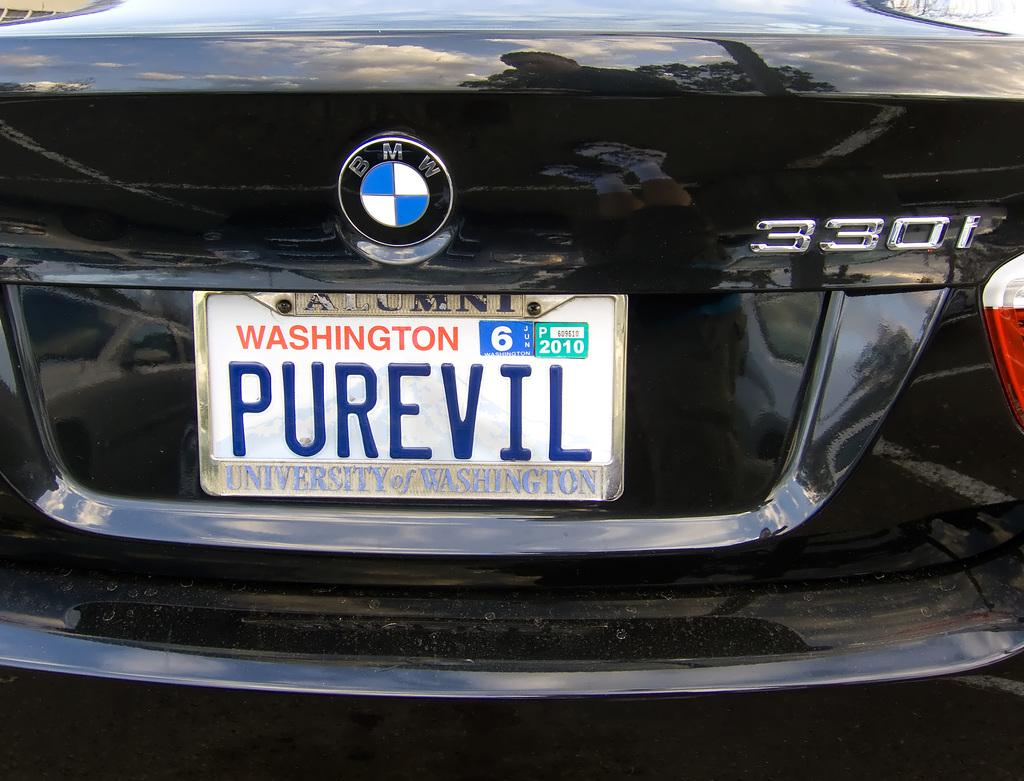<image>
Offer a succinct explanation of the picture presented. A BMW 330i has a Washington state license plate that reads PUREVIL. 